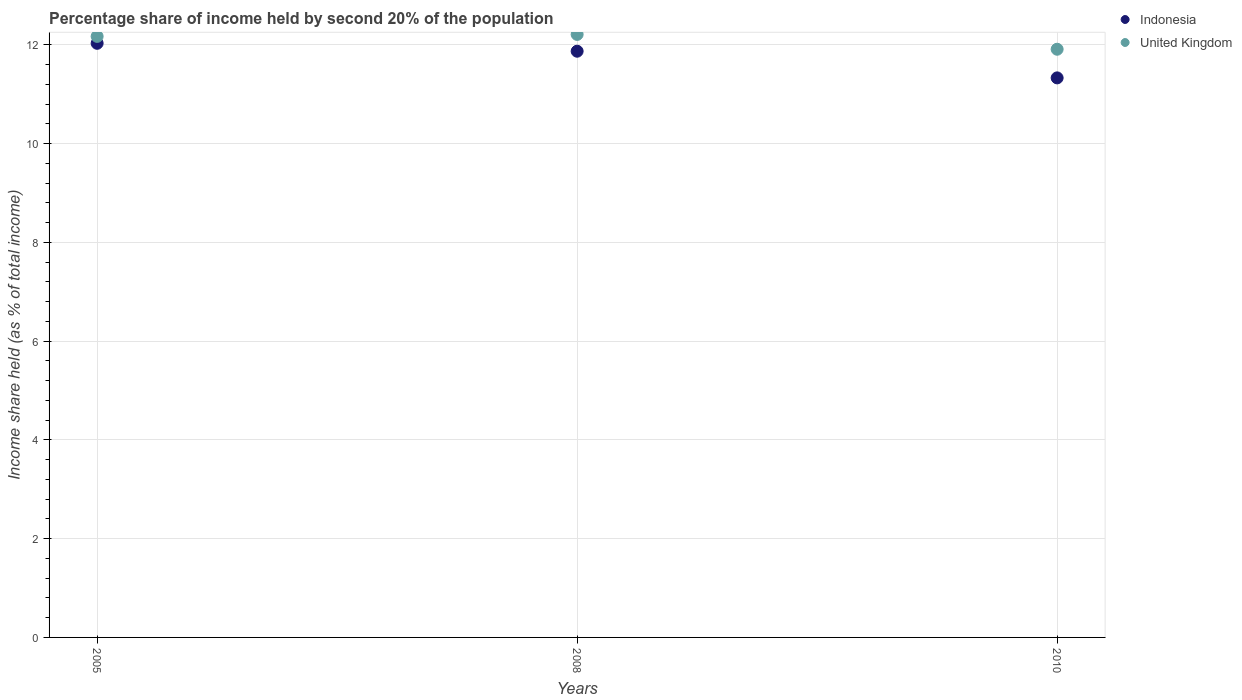Is the number of dotlines equal to the number of legend labels?
Ensure brevity in your answer.  Yes. What is the share of income held by second 20% of the population in Indonesia in 2010?
Keep it short and to the point. 11.33. Across all years, what is the maximum share of income held by second 20% of the population in Indonesia?
Make the answer very short. 12.03. Across all years, what is the minimum share of income held by second 20% of the population in Indonesia?
Your answer should be compact. 11.33. In which year was the share of income held by second 20% of the population in Indonesia maximum?
Your answer should be very brief. 2005. In which year was the share of income held by second 20% of the population in Indonesia minimum?
Give a very brief answer. 2010. What is the total share of income held by second 20% of the population in United Kingdom in the graph?
Give a very brief answer. 36.29. What is the difference between the share of income held by second 20% of the population in United Kingdom in 2008 and that in 2010?
Keep it short and to the point. 0.3. What is the difference between the share of income held by second 20% of the population in United Kingdom in 2005 and the share of income held by second 20% of the population in Indonesia in 2008?
Your response must be concise. 0.3. What is the average share of income held by second 20% of the population in United Kingdom per year?
Provide a succinct answer. 12.1. In the year 2010, what is the difference between the share of income held by second 20% of the population in United Kingdom and share of income held by second 20% of the population in Indonesia?
Your answer should be very brief. 0.58. In how many years, is the share of income held by second 20% of the population in Indonesia greater than 4.8 %?
Make the answer very short. 3. What is the ratio of the share of income held by second 20% of the population in United Kingdom in 2008 to that in 2010?
Give a very brief answer. 1.03. Is the share of income held by second 20% of the population in United Kingdom in 2005 less than that in 2008?
Your answer should be very brief. Yes. Is the difference between the share of income held by second 20% of the population in United Kingdom in 2005 and 2008 greater than the difference between the share of income held by second 20% of the population in Indonesia in 2005 and 2008?
Provide a succinct answer. No. What is the difference between the highest and the second highest share of income held by second 20% of the population in Indonesia?
Keep it short and to the point. 0.16. What is the difference between the highest and the lowest share of income held by second 20% of the population in United Kingdom?
Keep it short and to the point. 0.3. In how many years, is the share of income held by second 20% of the population in United Kingdom greater than the average share of income held by second 20% of the population in United Kingdom taken over all years?
Offer a very short reply. 2. Is the share of income held by second 20% of the population in Indonesia strictly greater than the share of income held by second 20% of the population in United Kingdom over the years?
Your answer should be very brief. No. Is the share of income held by second 20% of the population in United Kingdom strictly less than the share of income held by second 20% of the population in Indonesia over the years?
Give a very brief answer. No. How many years are there in the graph?
Provide a short and direct response. 3. Are the values on the major ticks of Y-axis written in scientific E-notation?
Provide a short and direct response. No. Does the graph contain grids?
Your answer should be compact. Yes. Where does the legend appear in the graph?
Your response must be concise. Top right. How many legend labels are there?
Give a very brief answer. 2. How are the legend labels stacked?
Offer a very short reply. Vertical. What is the title of the graph?
Offer a terse response. Percentage share of income held by second 20% of the population. What is the label or title of the X-axis?
Ensure brevity in your answer.  Years. What is the label or title of the Y-axis?
Offer a very short reply. Income share held (as % of total income). What is the Income share held (as % of total income) in Indonesia in 2005?
Your response must be concise. 12.03. What is the Income share held (as % of total income) in United Kingdom in 2005?
Offer a very short reply. 12.17. What is the Income share held (as % of total income) in Indonesia in 2008?
Your answer should be very brief. 11.87. What is the Income share held (as % of total income) of United Kingdom in 2008?
Provide a succinct answer. 12.21. What is the Income share held (as % of total income) of Indonesia in 2010?
Give a very brief answer. 11.33. What is the Income share held (as % of total income) of United Kingdom in 2010?
Your answer should be very brief. 11.91. Across all years, what is the maximum Income share held (as % of total income) of Indonesia?
Your response must be concise. 12.03. Across all years, what is the maximum Income share held (as % of total income) of United Kingdom?
Provide a succinct answer. 12.21. Across all years, what is the minimum Income share held (as % of total income) in Indonesia?
Give a very brief answer. 11.33. Across all years, what is the minimum Income share held (as % of total income) of United Kingdom?
Your response must be concise. 11.91. What is the total Income share held (as % of total income) in Indonesia in the graph?
Offer a very short reply. 35.23. What is the total Income share held (as % of total income) of United Kingdom in the graph?
Keep it short and to the point. 36.29. What is the difference between the Income share held (as % of total income) in Indonesia in 2005 and that in 2008?
Offer a terse response. 0.16. What is the difference between the Income share held (as % of total income) of United Kingdom in 2005 and that in 2008?
Offer a terse response. -0.04. What is the difference between the Income share held (as % of total income) in United Kingdom in 2005 and that in 2010?
Your answer should be very brief. 0.26. What is the difference between the Income share held (as % of total income) of Indonesia in 2008 and that in 2010?
Offer a terse response. 0.54. What is the difference between the Income share held (as % of total income) of United Kingdom in 2008 and that in 2010?
Your answer should be very brief. 0.3. What is the difference between the Income share held (as % of total income) in Indonesia in 2005 and the Income share held (as % of total income) in United Kingdom in 2008?
Offer a terse response. -0.18. What is the difference between the Income share held (as % of total income) in Indonesia in 2005 and the Income share held (as % of total income) in United Kingdom in 2010?
Provide a succinct answer. 0.12. What is the difference between the Income share held (as % of total income) of Indonesia in 2008 and the Income share held (as % of total income) of United Kingdom in 2010?
Your answer should be very brief. -0.04. What is the average Income share held (as % of total income) in Indonesia per year?
Make the answer very short. 11.74. What is the average Income share held (as % of total income) in United Kingdom per year?
Ensure brevity in your answer.  12.1. In the year 2005, what is the difference between the Income share held (as % of total income) of Indonesia and Income share held (as % of total income) of United Kingdom?
Offer a terse response. -0.14. In the year 2008, what is the difference between the Income share held (as % of total income) in Indonesia and Income share held (as % of total income) in United Kingdom?
Provide a short and direct response. -0.34. In the year 2010, what is the difference between the Income share held (as % of total income) in Indonesia and Income share held (as % of total income) in United Kingdom?
Give a very brief answer. -0.58. What is the ratio of the Income share held (as % of total income) of Indonesia in 2005 to that in 2008?
Offer a very short reply. 1.01. What is the ratio of the Income share held (as % of total income) in United Kingdom in 2005 to that in 2008?
Your answer should be very brief. 1. What is the ratio of the Income share held (as % of total income) of Indonesia in 2005 to that in 2010?
Keep it short and to the point. 1.06. What is the ratio of the Income share held (as % of total income) in United Kingdom in 2005 to that in 2010?
Offer a terse response. 1.02. What is the ratio of the Income share held (as % of total income) of Indonesia in 2008 to that in 2010?
Your answer should be very brief. 1.05. What is the ratio of the Income share held (as % of total income) of United Kingdom in 2008 to that in 2010?
Offer a very short reply. 1.03. What is the difference between the highest and the second highest Income share held (as % of total income) of Indonesia?
Your answer should be very brief. 0.16. What is the difference between the highest and the lowest Income share held (as % of total income) in United Kingdom?
Provide a succinct answer. 0.3. 